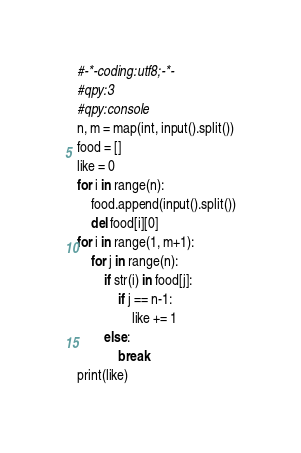Convert code to text. <code><loc_0><loc_0><loc_500><loc_500><_Python_>#-*-coding:utf8;-*-
#qpy:3
#qpy:console
n, m = map(int, input().split())
food = []
like = 0
for i in range(n):
    food.append(input().split())
    del food[i][0]
for i in range(1, m+1):
    for j in range(n):
        if str(i) in food[j]:
            if j == n-1:
                like += 1
        else:
            break
print(like)
</code> 